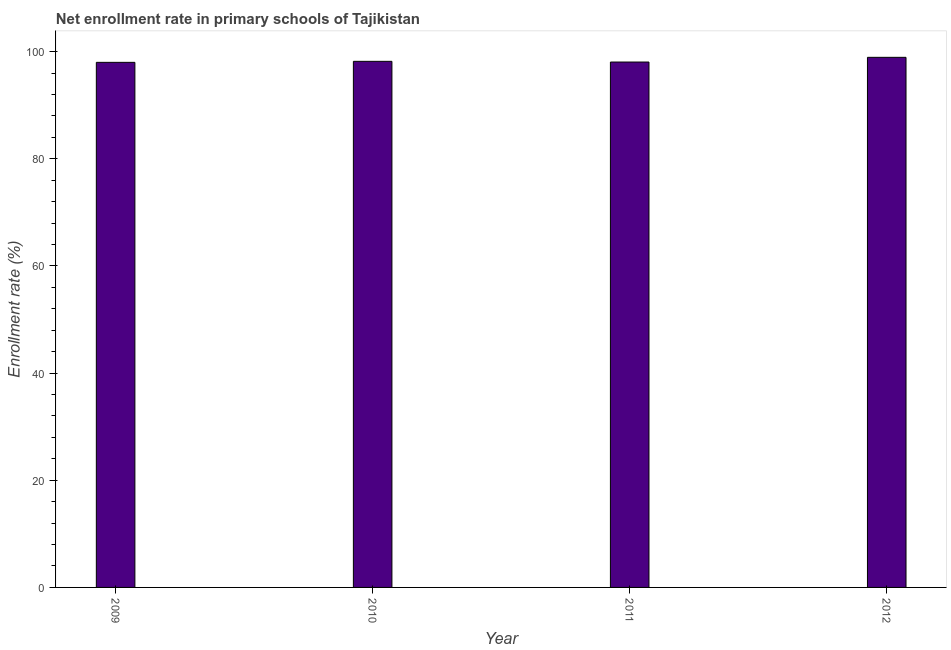Does the graph contain any zero values?
Ensure brevity in your answer.  No. Does the graph contain grids?
Provide a succinct answer. No. What is the title of the graph?
Your answer should be very brief. Net enrollment rate in primary schools of Tajikistan. What is the label or title of the Y-axis?
Make the answer very short. Enrollment rate (%). What is the net enrollment rate in primary schools in 2012?
Offer a terse response. 98.93. Across all years, what is the maximum net enrollment rate in primary schools?
Your answer should be compact. 98.93. Across all years, what is the minimum net enrollment rate in primary schools?
Ensure brevity in your answer.  97.99. In which year was the net enrollment rate in primary schools maximum?
Your answer should be compact. 2012. In which year was the net enrollment rate in primary schools minimum?
Provide a short and direct response. 2009. What is the sum of the net enrollment rate in primary schools?
Make the answer very short. 393.17. What is the difference between the net enrollment rate in primary schools in 2010 and 2011?
Offer a very short reply. 0.13. What is the average net enrollment rate in primary schools per year?
Your answer should be very brief. 98.29. What is the median net enrollment rate in primary schools?
Your answer should be very brief. 98.12. Do a majority of the years between 2009 and 2010 (inclusive) have net enrollment rate in primary schools greater than 80 %?
Give a very brief answer. Yes. Is the net enrollment rate in primary schools in 2009 less than that in 2012?
Offer a terse response. Yes. Is the difference between the net enrollment rate in primary schools in 2009 and 2012 greater than the difference between any two years?
Ensure brevity in your answer.  Yes. What is the difference between the highest and the second highest net enrollment rate in primary schools?
Provide a short and direct response. 0.75. What is the difference between the highest and the lowest net enrollment rate in primary schools?
Your answer should be compact. 0.94. How many bars are there?
Provide a succinct answer. 4. Are all the bars in the graph horizontal?
Ensure brevity in your answer.  No. How many years are there in the graph?
Offer a terse response. 4. What is the Enrollment rate (%) of 2009?
Provide a succinct answer. 97.99. What is the Enrollment rate (%) in 2010?
Make the answer very short. 98.18. What is the Enrollment rate (%) of 2011?
Keep it short and to the point. 98.05. What is the Enrollment rate (%) in 2012?
Your answer should be very brief. 98.93. What is the difference between the Enrollment rate (%) in 2009 and 2010?
Your response must be concise. -0.19. What is the difference between the Enrollment rate (%) in 2009 and 2011?
Your answer should be compact. -0.06. What is the difference between the Enrollment rate (%) in 2009 and 2012?
Ensure brevity in your answer.  -0.94. What is the difference between the Enrollment rate (%) in 2010 and 2011?
Offer a terse response. 0.13. What is the difference between the Enrollment rate (%) in 2010 and 2012?
Offer a terse response. -0.75. What is the difference between the Enrollment rate (%) in 2011 and 2012?
Your answer should be compact. -0.88. What is the ratio of the Enrollment rate (%) in 2009 to that in 2010?
Your answer should be very brief. 1. What is the ratio of the Enrollment rate (%) in 2009 to that in 2012?
Your response must be concise. 0.99. What is the ratio of the Enrollment rate (%) in 2010 to that in 2011?
Make the answer very short. 1. What is the ratio of the Enrollment rate (%) in 2010 to that in 2012?
Offer a very short reply. 0.99. What is the ratio of the Enrollment rate (%) in 2011 to that in 2012?
Offer a terse response. 0.99. 